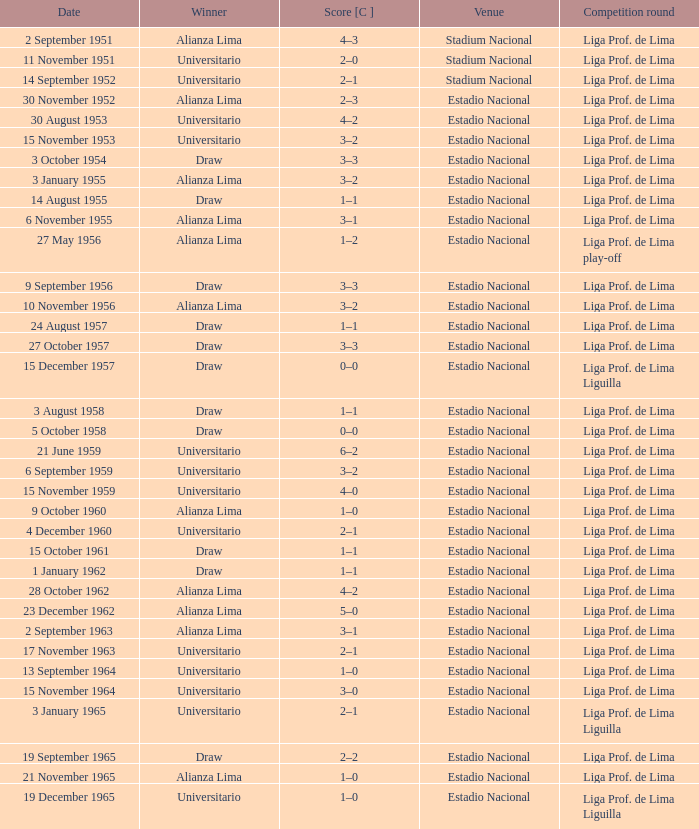What is the score of the event that Alianza Lima won in 1965? 1–0. 